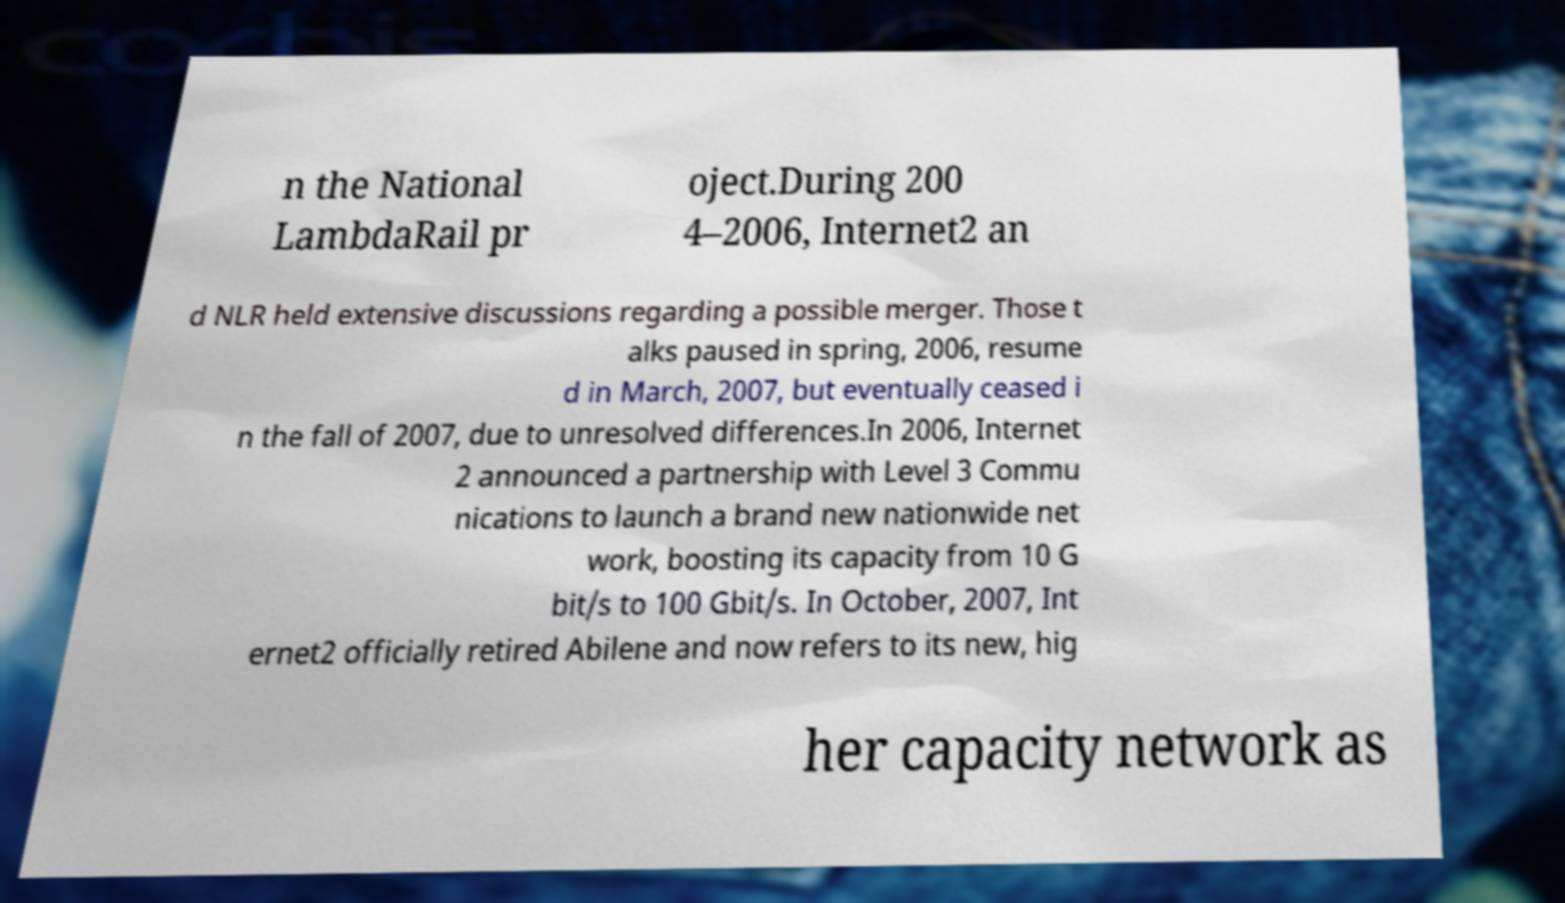There's text embedded in this image that I need extracted. Can you transcribe it verbatim? n the National LambdaRail pr oject.During 200 4–2006, Internet2 an d NLR held extensive discussions regarding a possible merger. Those t alks paused in spring, 2006, resume d in March, 2007, but eventually ceased i n the fall of 2007, due to unresolved differences.In 2006, Internet 2 announced a partnership with Level 3 Commu nications to launch a brand new nationwide net work, boosting its capacity from 10 G bit/s to 100 Gbit/s. In October, 2007, Int ernet2 officially retired Abilene and now refers to its new, hig her capacity network as 